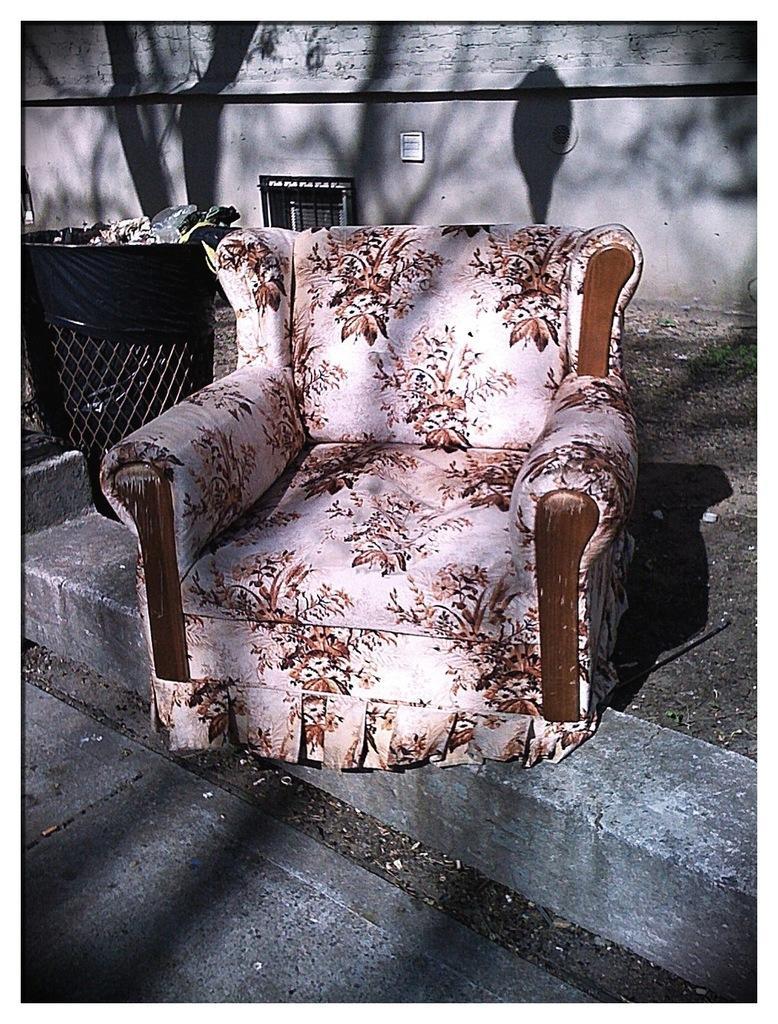Describe this image in one or two sentences. In this image I can see a white and brown colour sofa chair. I can also see shadows, a dustbin and in background I can see the wall. 